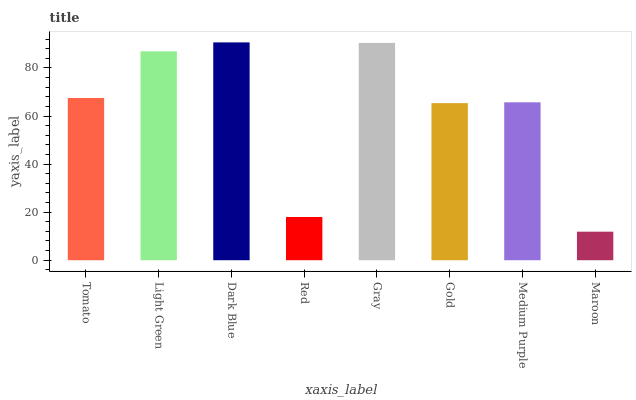Is Maroon the minimum?
Answer yes or no. Yes. Is Dark Blue the maximum?
Answer yes or no. Yes. Is Light Green the minimum?
Answer yes or no. No. Is Light Green the maximum?
Answer yes or no. No. Is Light Green greater than Tomato?
Answer yes or no. Yes. Is Tomato less than Light Green?
Answer yes or no. Yes. Is Tomato greater than Light Green?
Answer yes or no. No. Is Light Green less than Tomato?
Answer yes or no. No. Is Tomato the high median?
Answer yes or no. Yes. Is Medium Purple the low median?
Answer yes or no. Yes. Is Red the high median?
Answer yes or no. No. Is Light Green the low median?
Answer yes or no. No. 